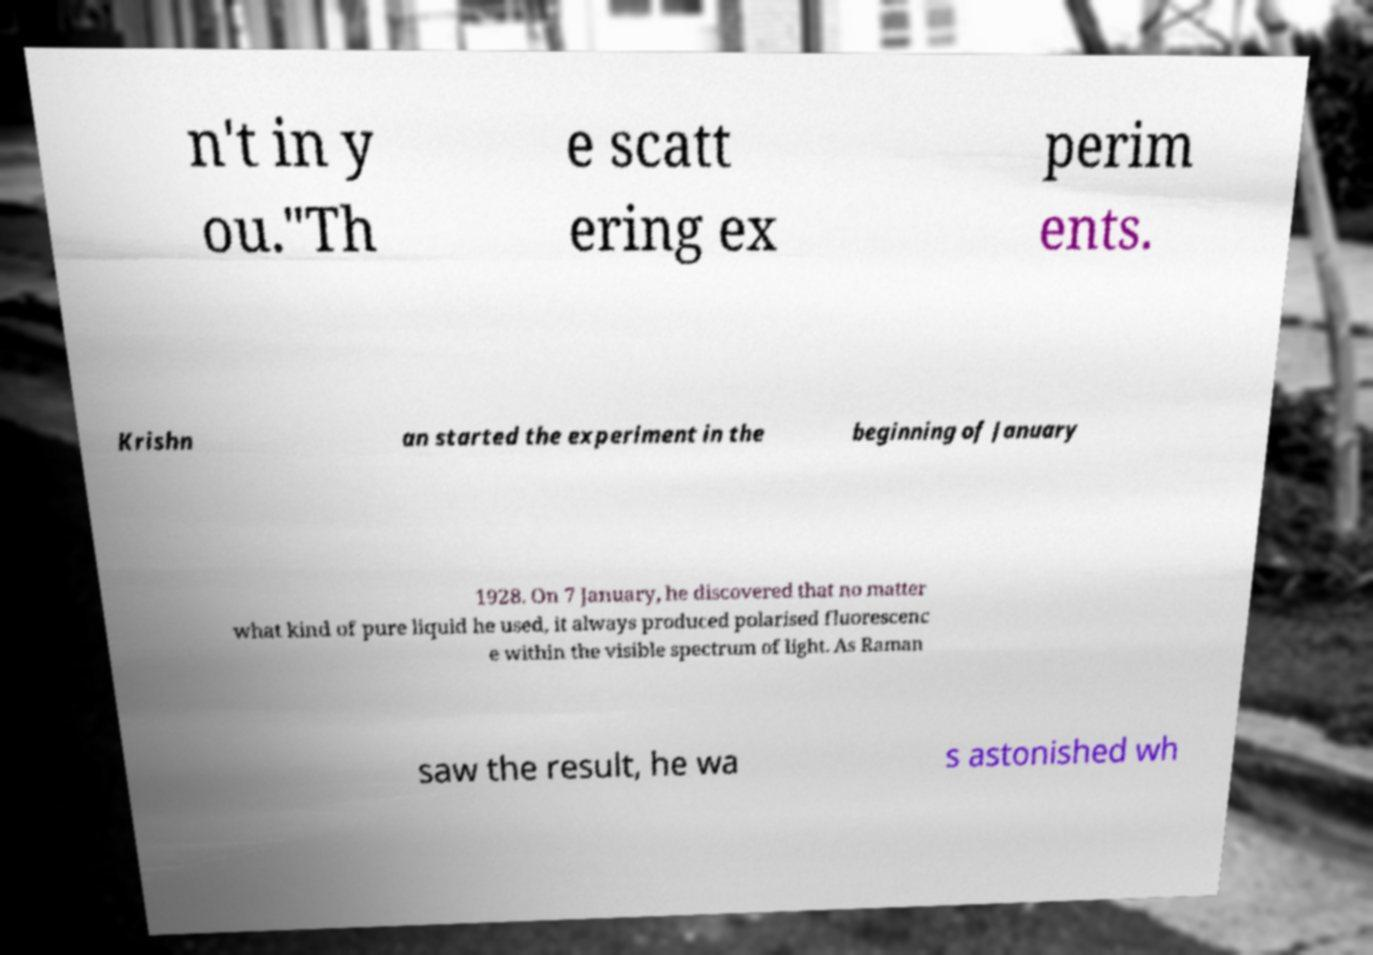What messages or text are displayed in this image? I need them in a readable, typed format. n't in y ou."Th e scatt ering ex perim ents. Krishn an started the experiment in the beginning of January 1928. On 7 January, he discovered that no matter what kind of pure liquid he used, it always produced polarised fluorescenc e within the visible spectrum of light. As Raman saw the result, he wa s astonished wh 